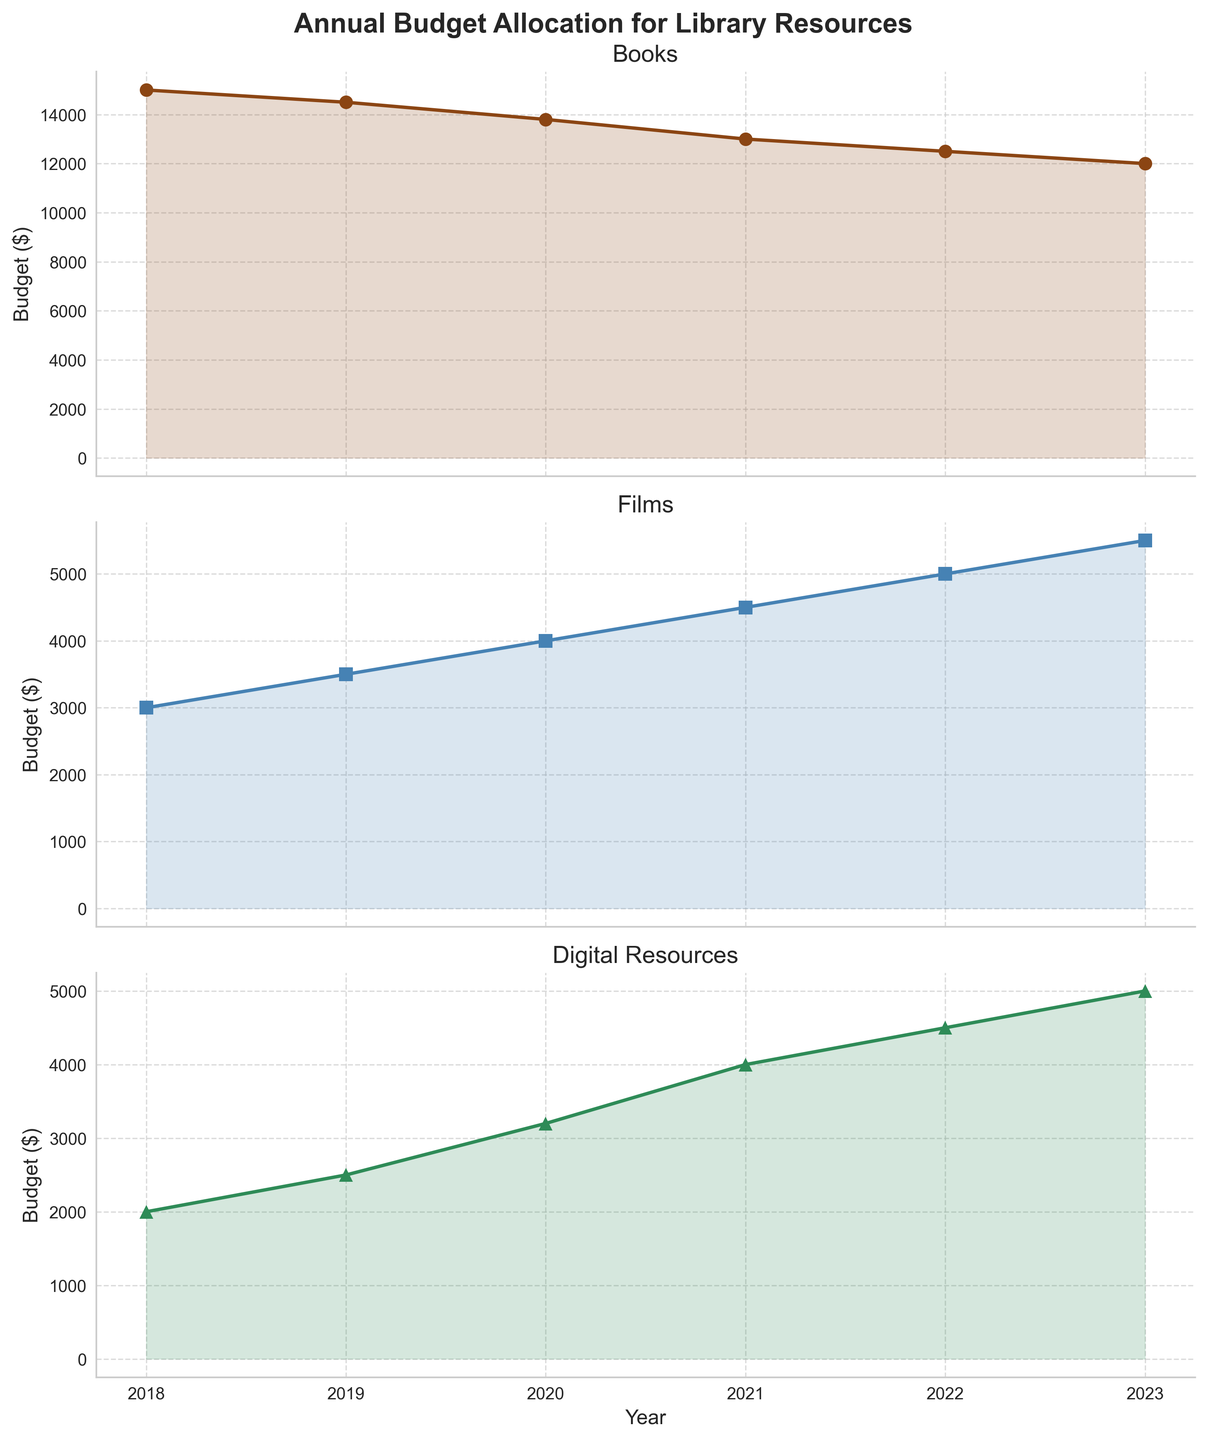What is the title of the figure? The title is at the top of the figure, just above the subplots.
Answer: Annual Budget Allocation for Library Resources How many subplots are there in the figure? By counting, you can see that there are three subplots stacked vertically.
Answer: 3 Which media type has the most significant increase in budget from 2018 to 2023? By observing the slope of the lines in the subplots, you can see that the budget for Films increases the most significantly.
Answer: Films What is the budget for digital resources in 2021? Look at the value on the Digital Resources line for the year 2021.
Answer: 4000 In which year did the budget allocation for books first drop below $14000? Observe the Books subplot and identify the first year the line dips below the $14000 mark.
Answer: 2020 What's the total budget for all three media types in 2022? Sum the budgets for Books, Films, and Digital Resources in the year 2022: 12500 + 5000 + 4500
Answer: 22000 Between which two consecutive years did the budget for films increase the most? Calculate the differences between each pair of consecutive years for Films and identify the largest difference: 500 (2018-2019), 500 (2019-2020), 500 (2020-2021), 500 (2021-2022), 500 (2022-2023).
Answer: 2022-2023 What is the average annual budget for books from 2018 to 2023? Add the annual budgets for Books and divide by the number of years: (15000 + 14500 + 13800 + 13000 + 12500 + 12000) / 6
Answer: 13466.67 In which year did the budget for digital resources exceed the budget for books and films, if at all? Identify if there is any year where the budget for digital resources is greater than both the budgets for books and films.
Answer: None Which media type had the smallest budget allocation in 2018? Compare the 2018 budget values for Books, Films, and Digital Resources.
Answer: Digital Resources 